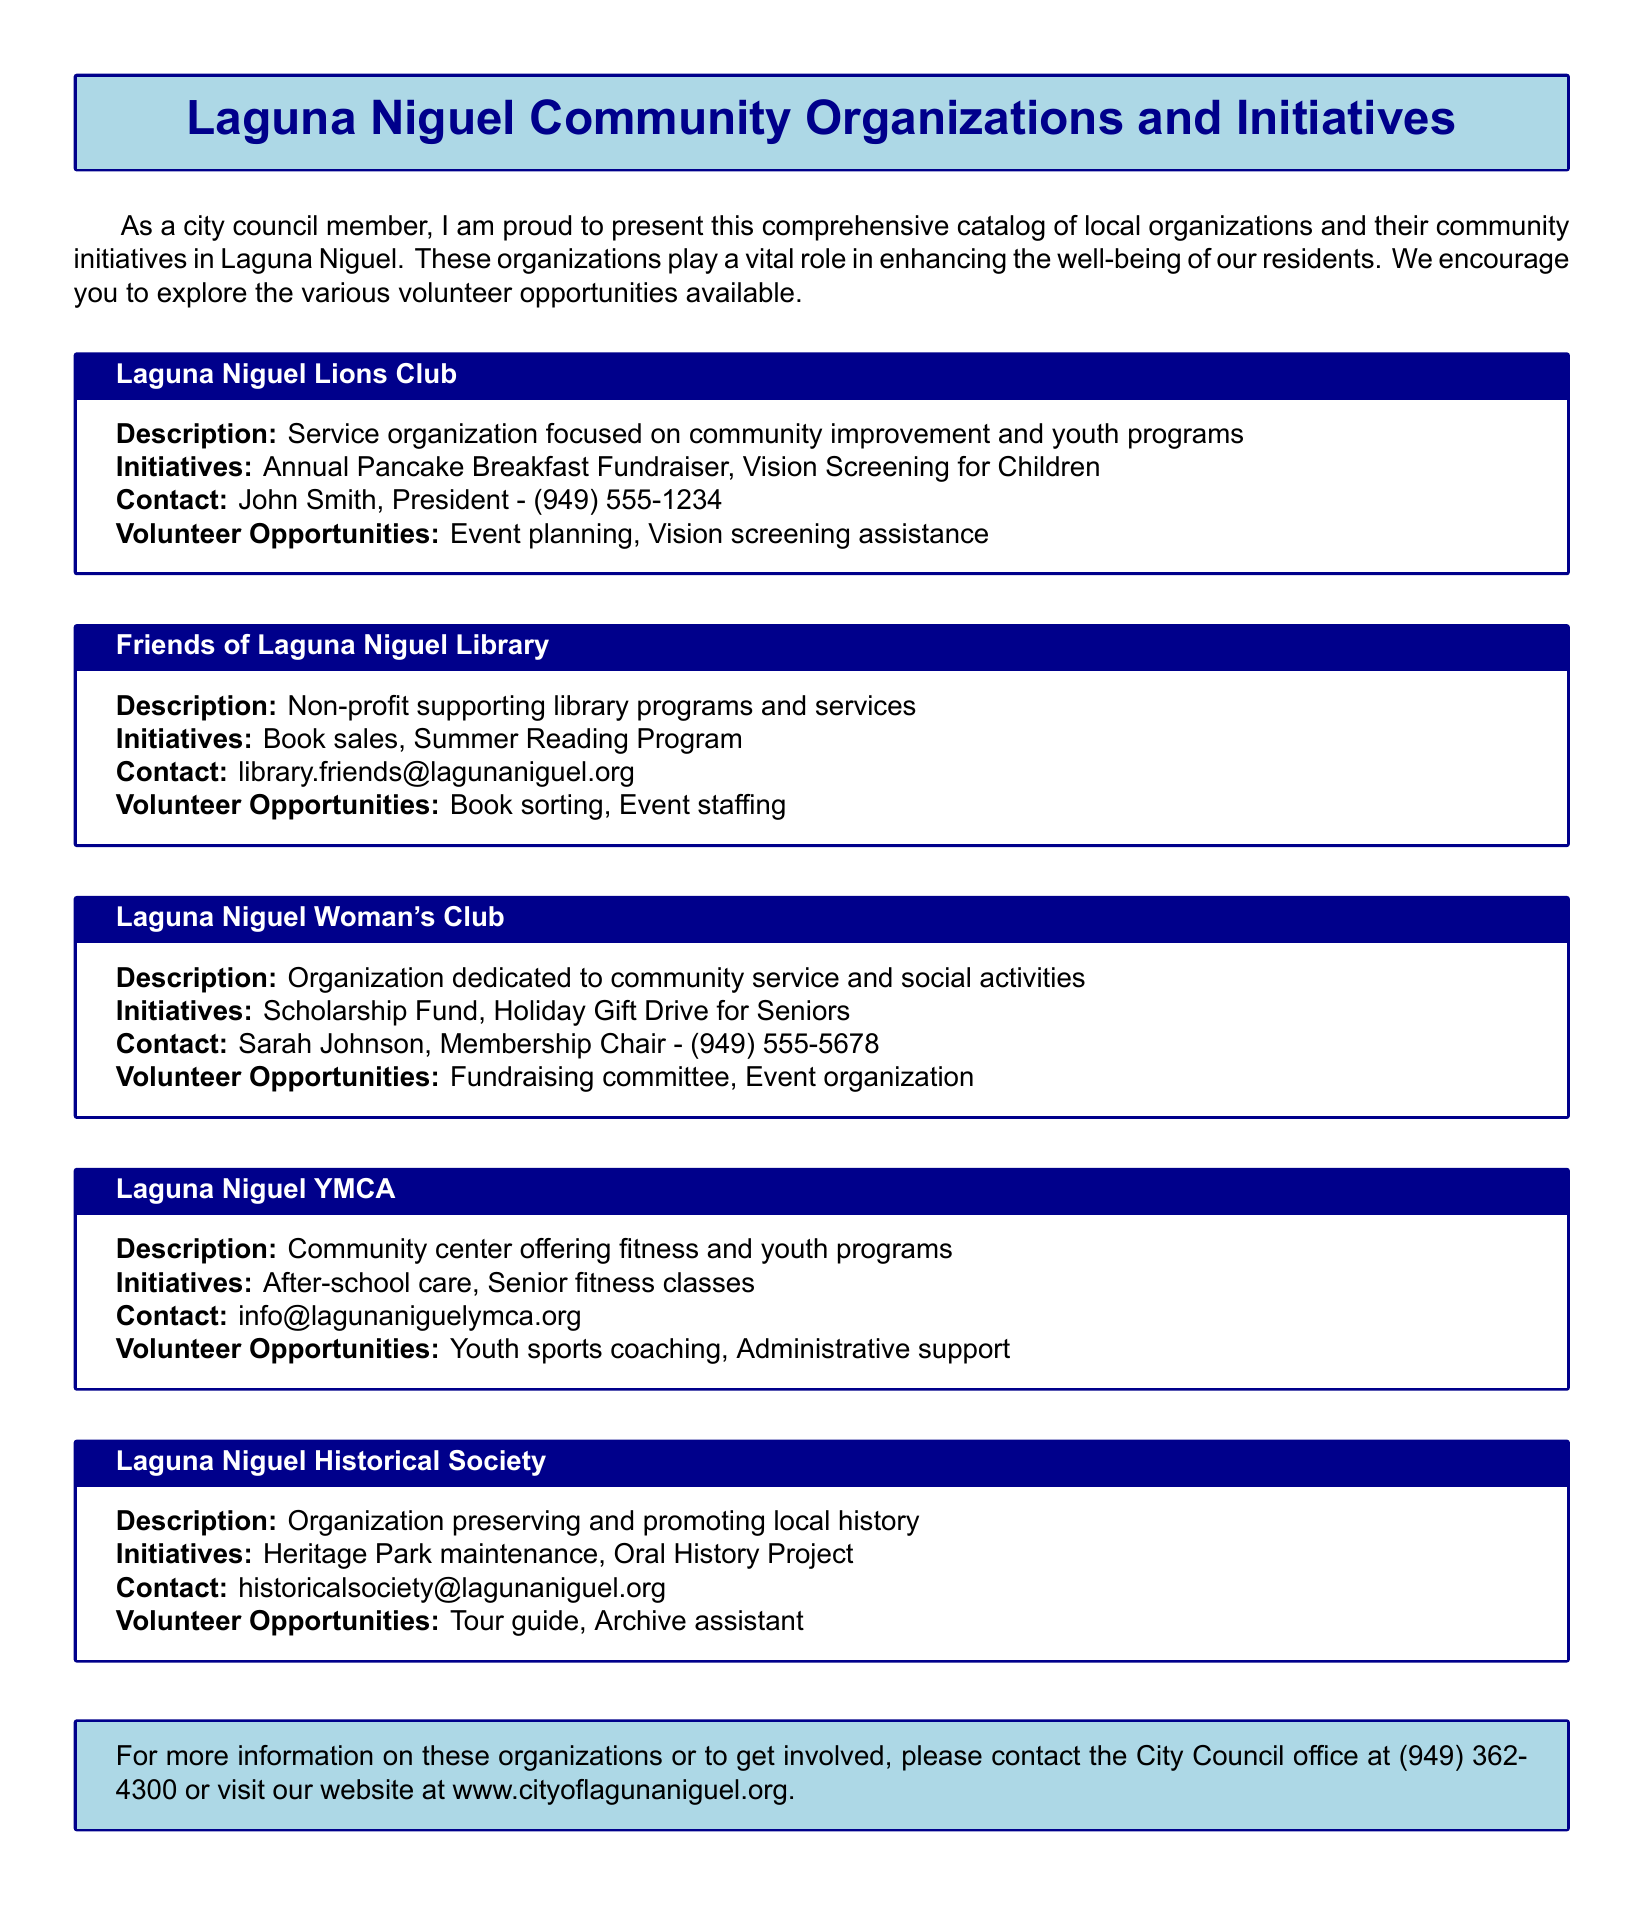What is the name of the organization focused on community improvement? The document states that the Laguna Niguel Lions Club is focused on community improvement and youth programs.
Answer: Laguna Niguel Lions Club Who is the contact person for the Laguna Niguel Woman's Club? According to the document, Sarah Johnson is the Membership Chair and the contact person for the Laguna Niguel Woman's Club.
Answer: Sarah Johnson What initiative does the Friends of Laguna Niguel Library organize? The document mentions that the Friends of Laguna Niguel Library organizes book sales and a Summer Reading Program.
Answer: Book sales What type of volunteer opportunities does the Laguna Niguel YMCA offer? The document specifies that the Laguna Niguel YMCA offers volunteer opportunities in youth sports coaching and administrative support.
Answer: Youth sports coaching, Administrative support Which organization's initiative includes a Holiday Gift Drive for Seniors? The document highlights that the Laguna Niguel Woman's Club has an initiative for a Holiday Gift Drive for Seniors.
Answer: Laguna Niguel Woman's Club How can one contact the City Council office for more information? The document provides the contact number for the City Council office as (949) 362-4300 for more information.
Answer: (949) 362-4300 What is the primary focus of the Laguna Niguel Historical Society? It is indicated in the document that the primary focus of the Laguna Niguel Historical Society is to preserve and promote local history.
Answer: Preserve and promote local history How many initiatives does the Laguna Niguel Lions Club have listed? The document lists two initiatives for the Laguna Niguel Lions Club: Annual Pancake Breakfast Fundraiser and Vision Screening for Children.
Answer: Two What is the email contact for the Laguna Niguel Historical Society? The document lists the email contact for the Laguna Niguel Historical Society as historicalsociety@lagunaniguel.org.
Answer: historicalsociety@lagunaniguel.org 